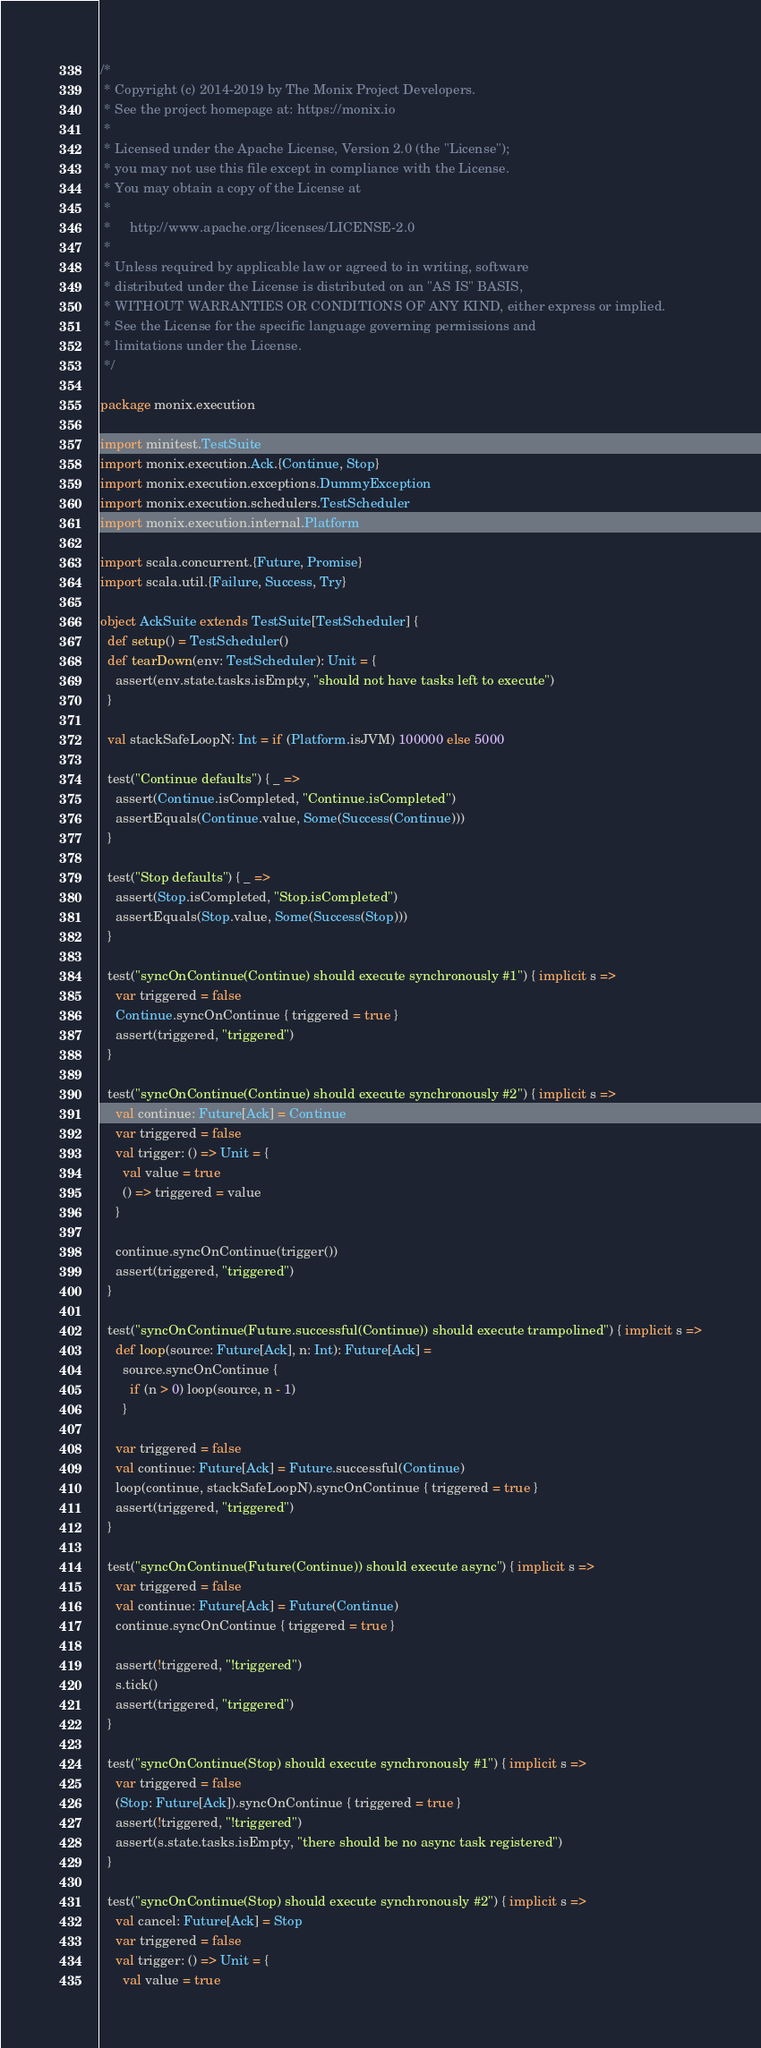<code> <loc_0><loc_0><loc_500><loc_500><_Scala_>/*
 * Copyright (c) 2014-2019 by The Monix Project Developers.
 * See the project homepage at: https://monix.io
 *
 * Licensed under the Apache License, Version 2.0 (the "License");
 * you may not use this file except in compliance with the License.
 * You may obtain a copy of the License at
 *
 *     http://www.apache.org/licenses/LICENSE-2.0
 *
 * Unless required by applicable law or agreed to in writing, software
 * distributed under the License is distributed on an "AS IS" BASIS,
 * WITHOUT WARRANTIES OR CONDITIONS OF ANY KIND, either express or implied.
 * See the License for the specific language governing permissions and
 * limitations under the License.
 */

package monix.execution

import minitest.TestSuite
import monix.execution.Ack.{Continue, Stop}
import monix.execution.exceptions.DummyException
import monix.execution.schedulers.TestScheduler
import monix.execution.internal.Platform

import scala.concurrent.{Future, Promise}
import scala.util.{Failure, Success, Try}

object AckSuite extends TestSuite[TestScheduler] {
  def setup() = TestScheduler()
  def tearDown(env: TestScheduler): Unit = {
    assert(env.state.tasks.isEmpty, "should not have tasks left to execute")
  }

  val stackSafeLoopN: Int = if (Platform.isJVM) 100000 else 5000

  test("Continue defaults") { _ =>
    assert(Continue.isCompleted, "Continue.isCompleted")
    assertEquals(Continue.value, Some(Success(Continue)))
  }

  test("Stop defaults") { _ =>
    assert(Stop.isCompleted, "Stop.isCompleted")
    assertEquals(Stop.value, Some(Success(Stop)))
  }

  test("syncOnContinue(Continue) should execute synchronously #1") { implicit s =>
    var triggered = false
    Continue.syncOnContinue { triggered = true }
    assert(triggered, "triggered")
  }

  test("syncOnContinue(Continue) should execute synchronously #2") { implicit s =>
    val continue: Future[Ack] = Continue
    var triggered = false
    val trigger: () => Unit = {
      val value = true
      () => triggered = value
    }

    continue.syncOnContinue(trigger())
    assert(triggered, "triggered")
  }

  test("syncOnContinue(Future.successful(Continue)) should execute trampolined") { implicit s =>
    def loop(source: Future[Ack], n: Int): Future[Ack] =
      source.syncOnContinue {
        if (n > 0) loop(source, n - 1)
      }

    var triggered = false
    val continue: Future[Ack] = Future.successful(Continue)
    loop(continue, stackSafeLoopN).syncOnContinue { triggered = true }
    assert(triggered, "triggered")
  }

  test("syncOnContinue(Future(Continue)) should execute async") { implicit s =>
    var triggered = false
    val continue: Future[Ack] = Future(Continue)
    continue.syncOnContinue { triggered = true }

    assert(!triggered, "!triggered")
    s.tick()
    assert(triggered, "triggered")
  }

  test("syncOnContinue(Stop) should execute synchronously #1") { implicit s =>
    var triggered = false
    (Stop: Future[Ack]).syncOnContinue { triggered = true }
    assert(!triggered, "!triggered")
    assert(s.state.tasks.isEmpty, "there should be no async task registered")
  }

  test("syncOnContinue(Stop) should execute synchronously #2") { implicit s =>
    val cancel: Future[Ack] = Stop
    var triggered = false
    val trigger: () => Unit = {
      val value = true</code> 